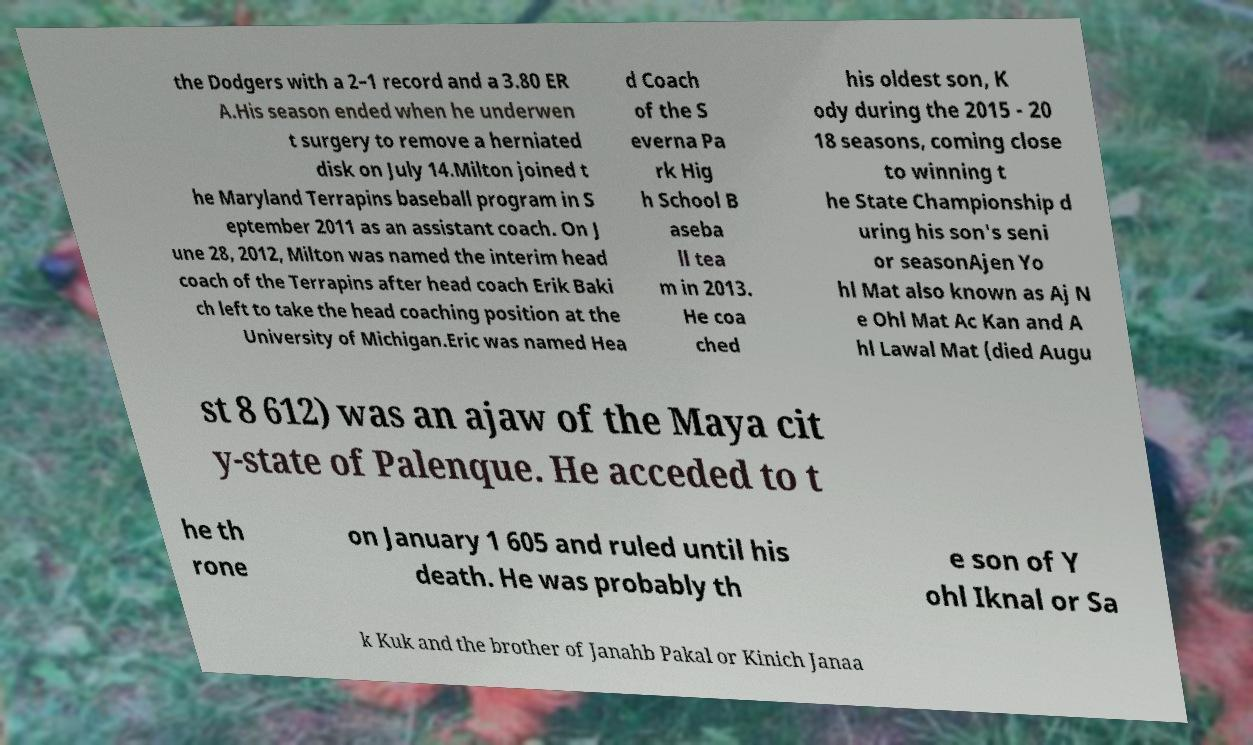There's text embedded in this image that I need extracted. Can you transcribe it verbatim? the Dodgers with a 2–1 record and a 3.80 ER A.His season ended when he underwen t surgery to remove a herniated disk on July 14.Milton joined t he Maryland Terrapins baseball program in S eptember 2011 as an assistant coach. On J une 28, 2012, Milton was named the interim head coach of the Terrapins after head coach Erik Baki ch left to take the head coaching position at the University of Michigan.Eric was named Hea d Coach of the S everna Pa rk Hig h School B aseba ll tea m in 2013. He coa ched his oldest son, K ody during the 2015 - 20 18 seasons, coming close to winning t he State Championship d uring his son's seni or seasonAjen Yo hl Mat also known as Aj N e Ohl Mat Ac Kan and A hl Lawal Mat (died Augu st 8 612) was an ajaw of the Maya cit y-state of Palenque. He acceded to t he th rone on January 1 605 and ruled until his death. He was probably th e son of Y ohl Iknal or Sa k Kuk and the brother of Janahb Pakal or Kinich Janaa 